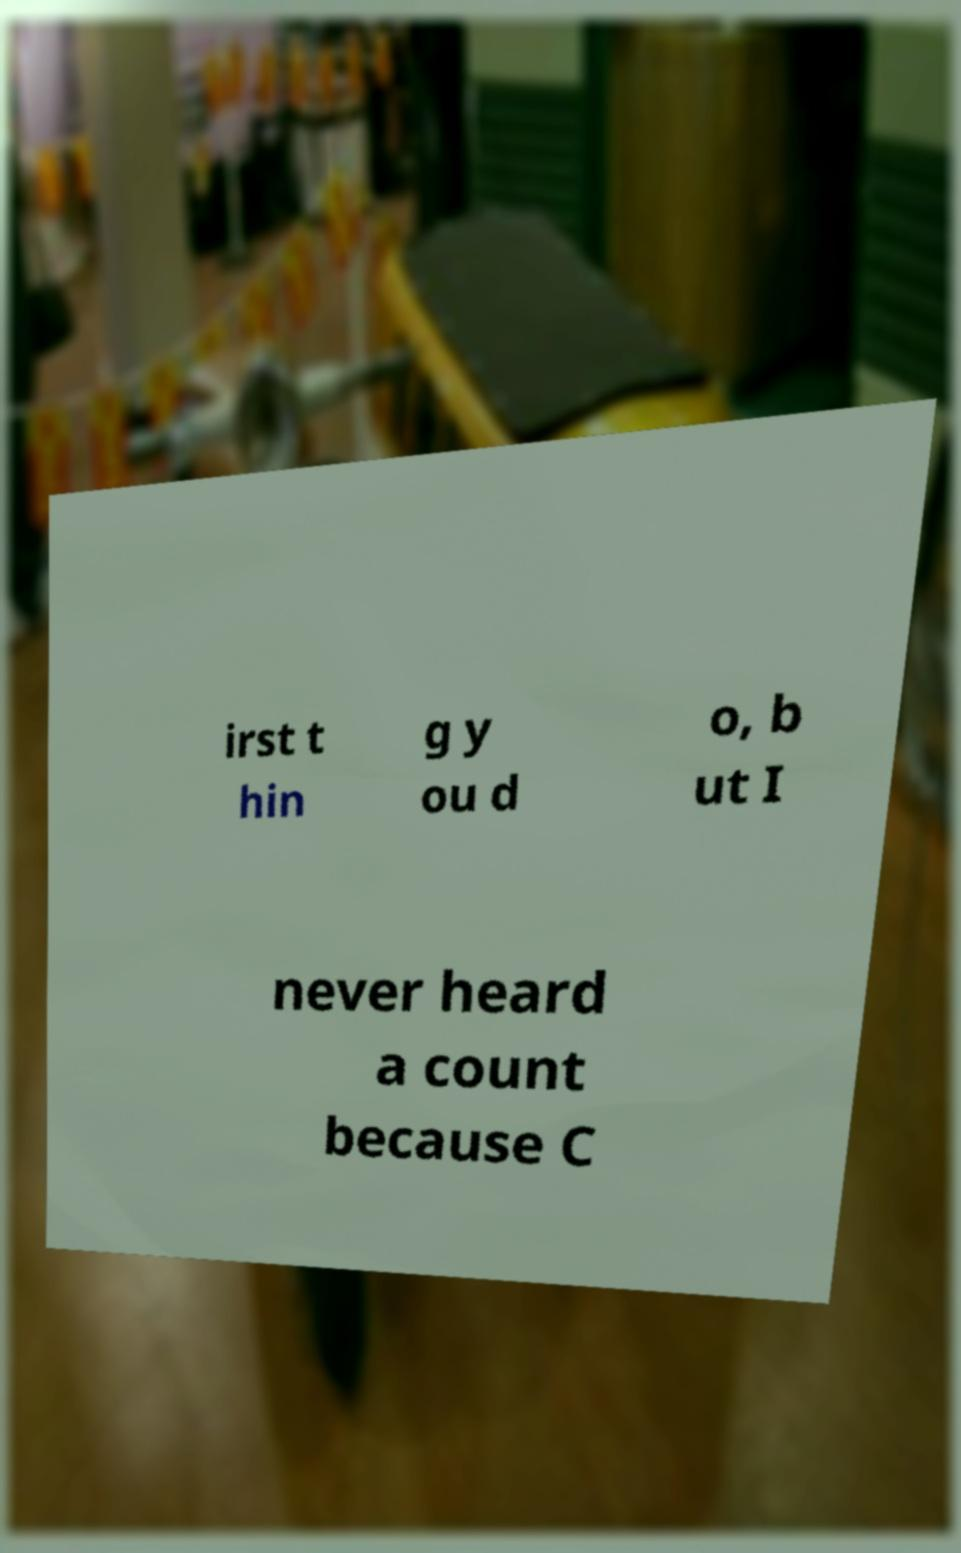Could you assist in decoding the text presented in this image and type it out clearly? irst t hin g y ou d o, b ut I never heard a count because C 